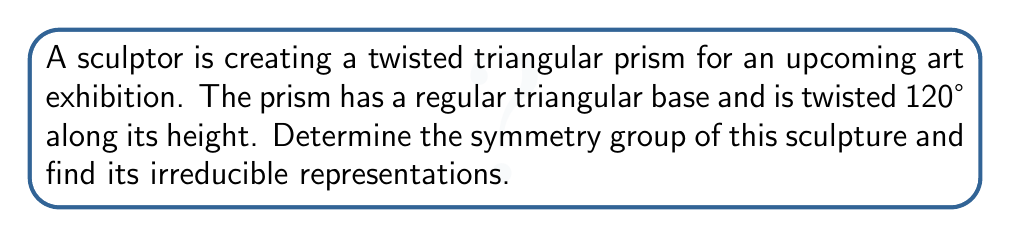Teach me how to tackle this problem. 1. Identify the symmetry group:
   The symmetry group of this twisted triangular prism is $D_3$, the dihedral group of order 6.

2. Elements of $D_3$:
   - Identity: $e$
   - Rotations: $r$ (120° rotation), $r^2$ (240° rotation)
   - Reflections: $s$, $sr$, $sr^2$

3. Character table of $D_3$:
   $$
   \begin{array}{c|ccc}
   D_3 & e & 2r & 3s \\
   \hline
   A_1 & 1 & 1 & 1 \\
   A_2 & 1 & 1 & -1 \\
   E & 2 & -1 & 0
   \end{array}
   $$

4. Irreducible representations:
   - $A_1$: 1-dimensional trivial representation
   - $A_2$: 1-dimensional sign representation
   - $E$: 2-dimensional standard representation

5. Geometric interpretation:
   - $A_1$ represents invariance under all symmetries
   - $A_2$ represents invariance under rotations but sign change under reflections
   - $E$ represents the natural action of $D_3$ on the plane

6. Physical interpretation for the sculpture:
   - $A_1$ corresponds to uniform coloring or texture
   - $A_2$ could represent a chiral pattern that reverses under reflection
   - $E$ could represent the actual geometric transformations of the prism
Answer: Symmetry group: $D_3$. Irreducible representations: $A_1$, $A_2$, and $E$. 